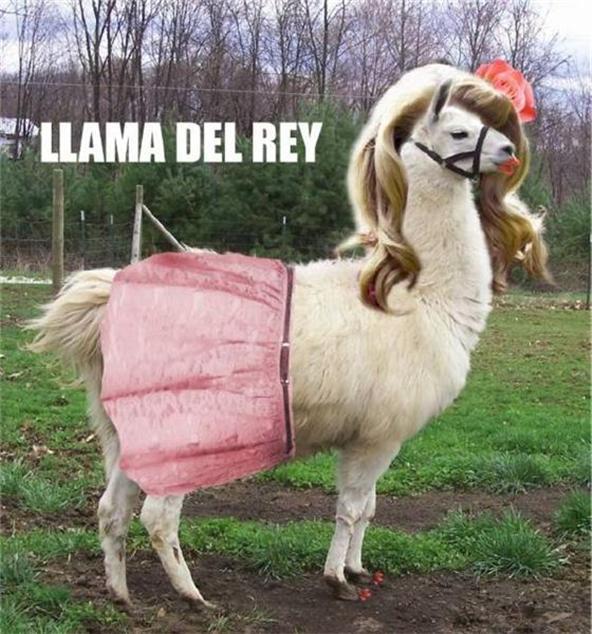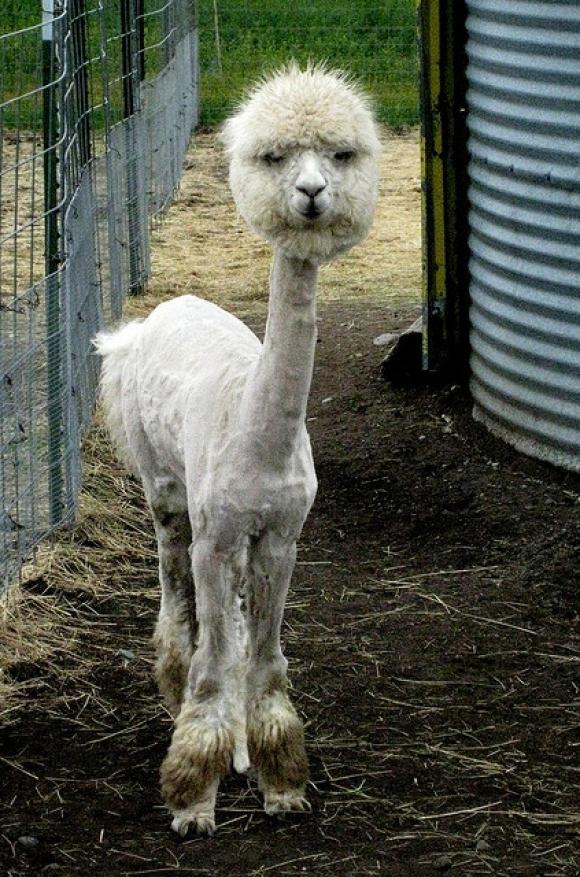The first image is the image on the left, the second image is the image on the right. For the images shown, is this caption "Something is wearing pink." true? Answer yes or no. Yes. The first image is the image on the left, the second image is the image on the right. Given the left and right images, does the statement "At least one person can be seen holding reins." hold true? Answer yes or no. No. 